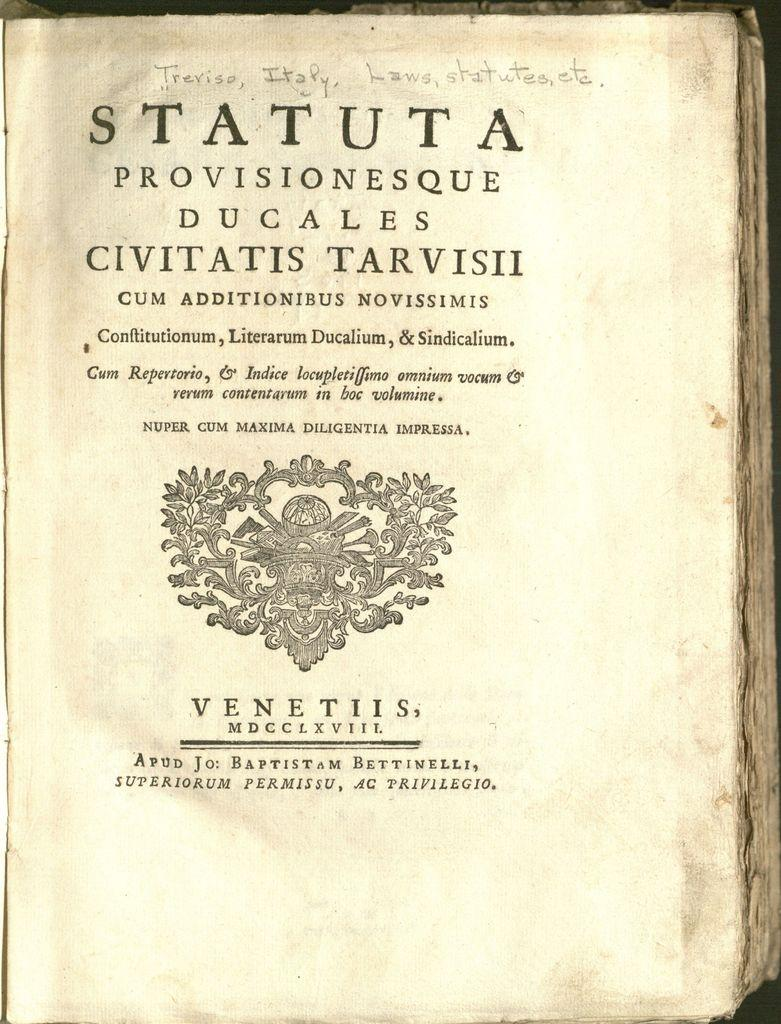<image>
Write a terse but informative summary of the picture. A book opened to a page reading STATUTA in a different language. 